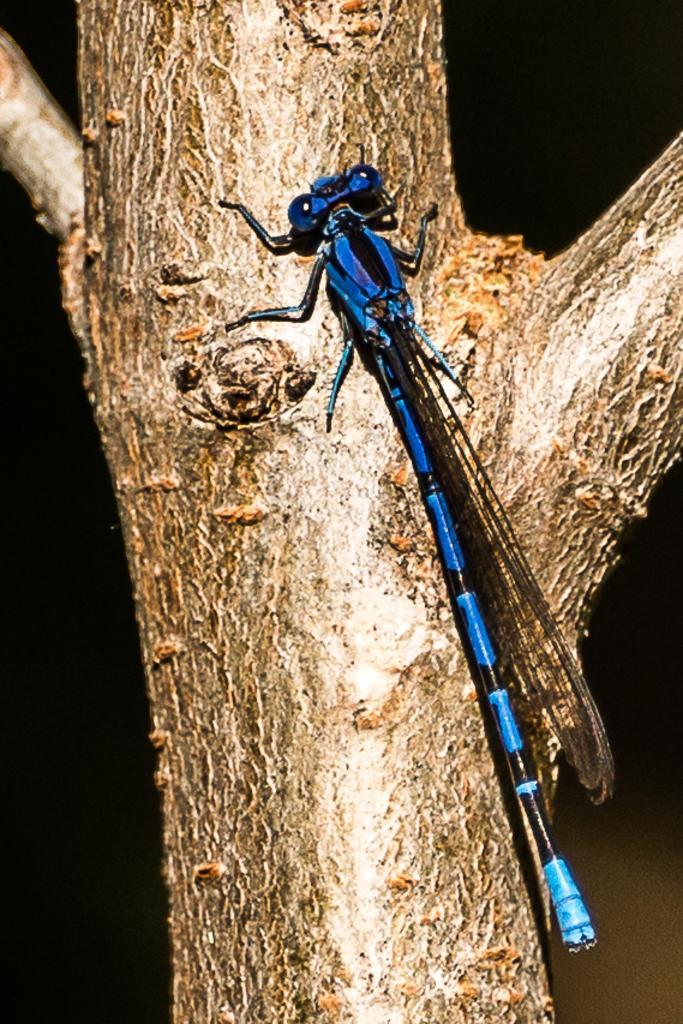How would you summarize this image in a sentence or two? In this image we can see a blue color fly is sitting on the bark of the tree. 